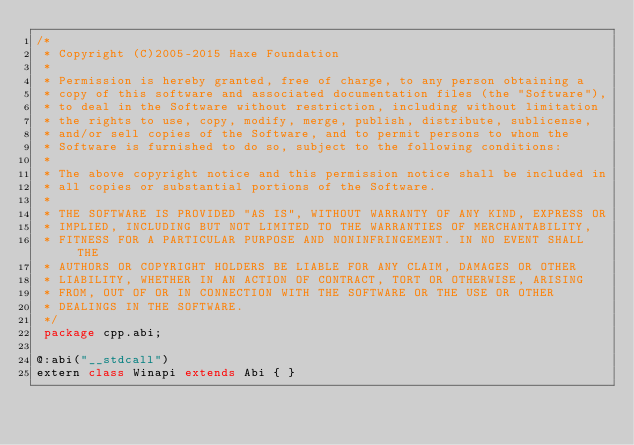Convert code to text. <code><loc_0><loc_0><loc_500><loc_500><_Haxe_>/*
 * Copyright (C)2005-2015 Haxe Foundation
 *
 * Permission is hereby granted, free of charge, to any person obtaining a
 * copy of this software and associated documentation files (the "Software"),
 * to deal in the Software without restriction, including without limitation
 * the rights to use, copy, modify, merge, publish, distribute, sublicense,
 * and/or sell copies of the Software, and to permit persons to whom the
 * Software is furnished to do so, subject to the following conditions:
 *
 * The above copyright notice and this permission notice shall be included in
 * all copies or substantial portions of the Software.
 *
 * THE SOFTWARE IS PROVIDED "AS IS", WITHOUT WARRANTY OF ANY KIND, EXPRESS OR
 * IMPLIED, INCLUDING BUT NOT LIMITED TO THE WARRANTIES OF MERCHANTABILITY,
 * FITNESS FOR A PARTICULAR PURPOSE AND NONINFRINGEMENT. IN NO EVENT SHALL THE
 * AUTHORS OR COPYRIGHT HOLDERS BE LIABLE FOR ANY CLAIM, DAMAGES OR OTHER
 * LIABILITY, WHETHER IN AN ACTION OF CONTRACT, TORT OR OTHERWISE, ARISING
 * FROM, OUT OF OR IN CONNECTION WITH THE SOFTWARE OR THE USE OR OTHER
 * DEALINGS IN THE SOFTWARE.
 */
 package cpp.abi;

@:abi("__stdcall")
extern class Winapi extends Abi { }
</code> 